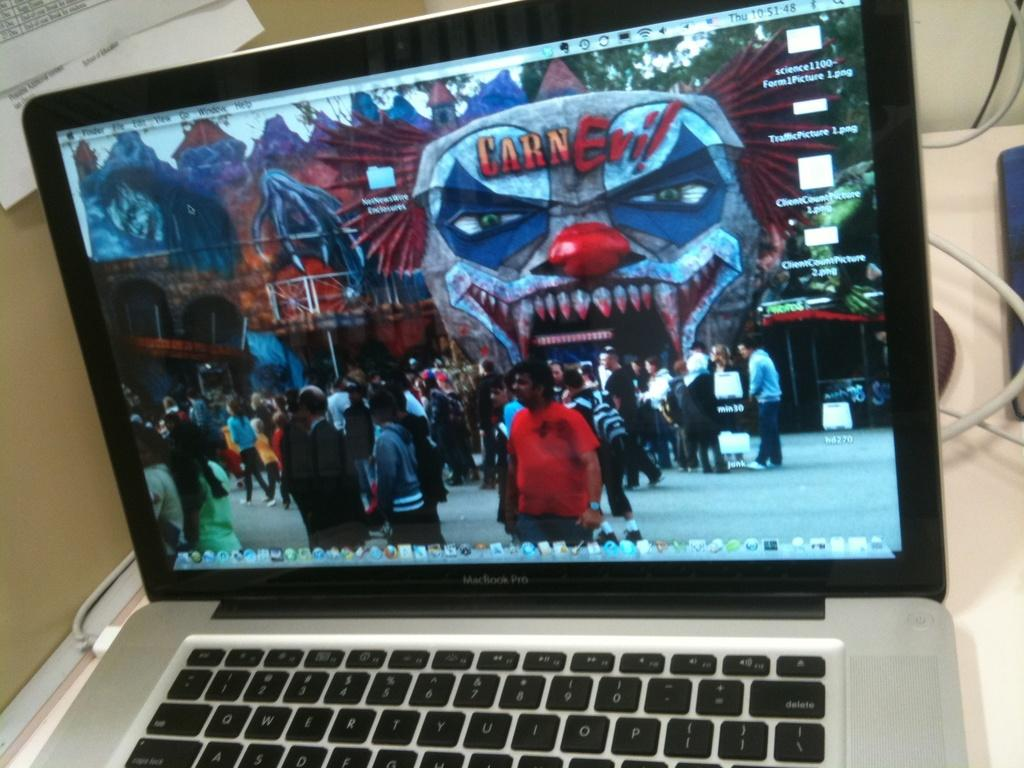<image>
Present a compact description of the photo's key features. A laptop showing a scene with a structure shaped like a clown with the term CarnEvil on it. 